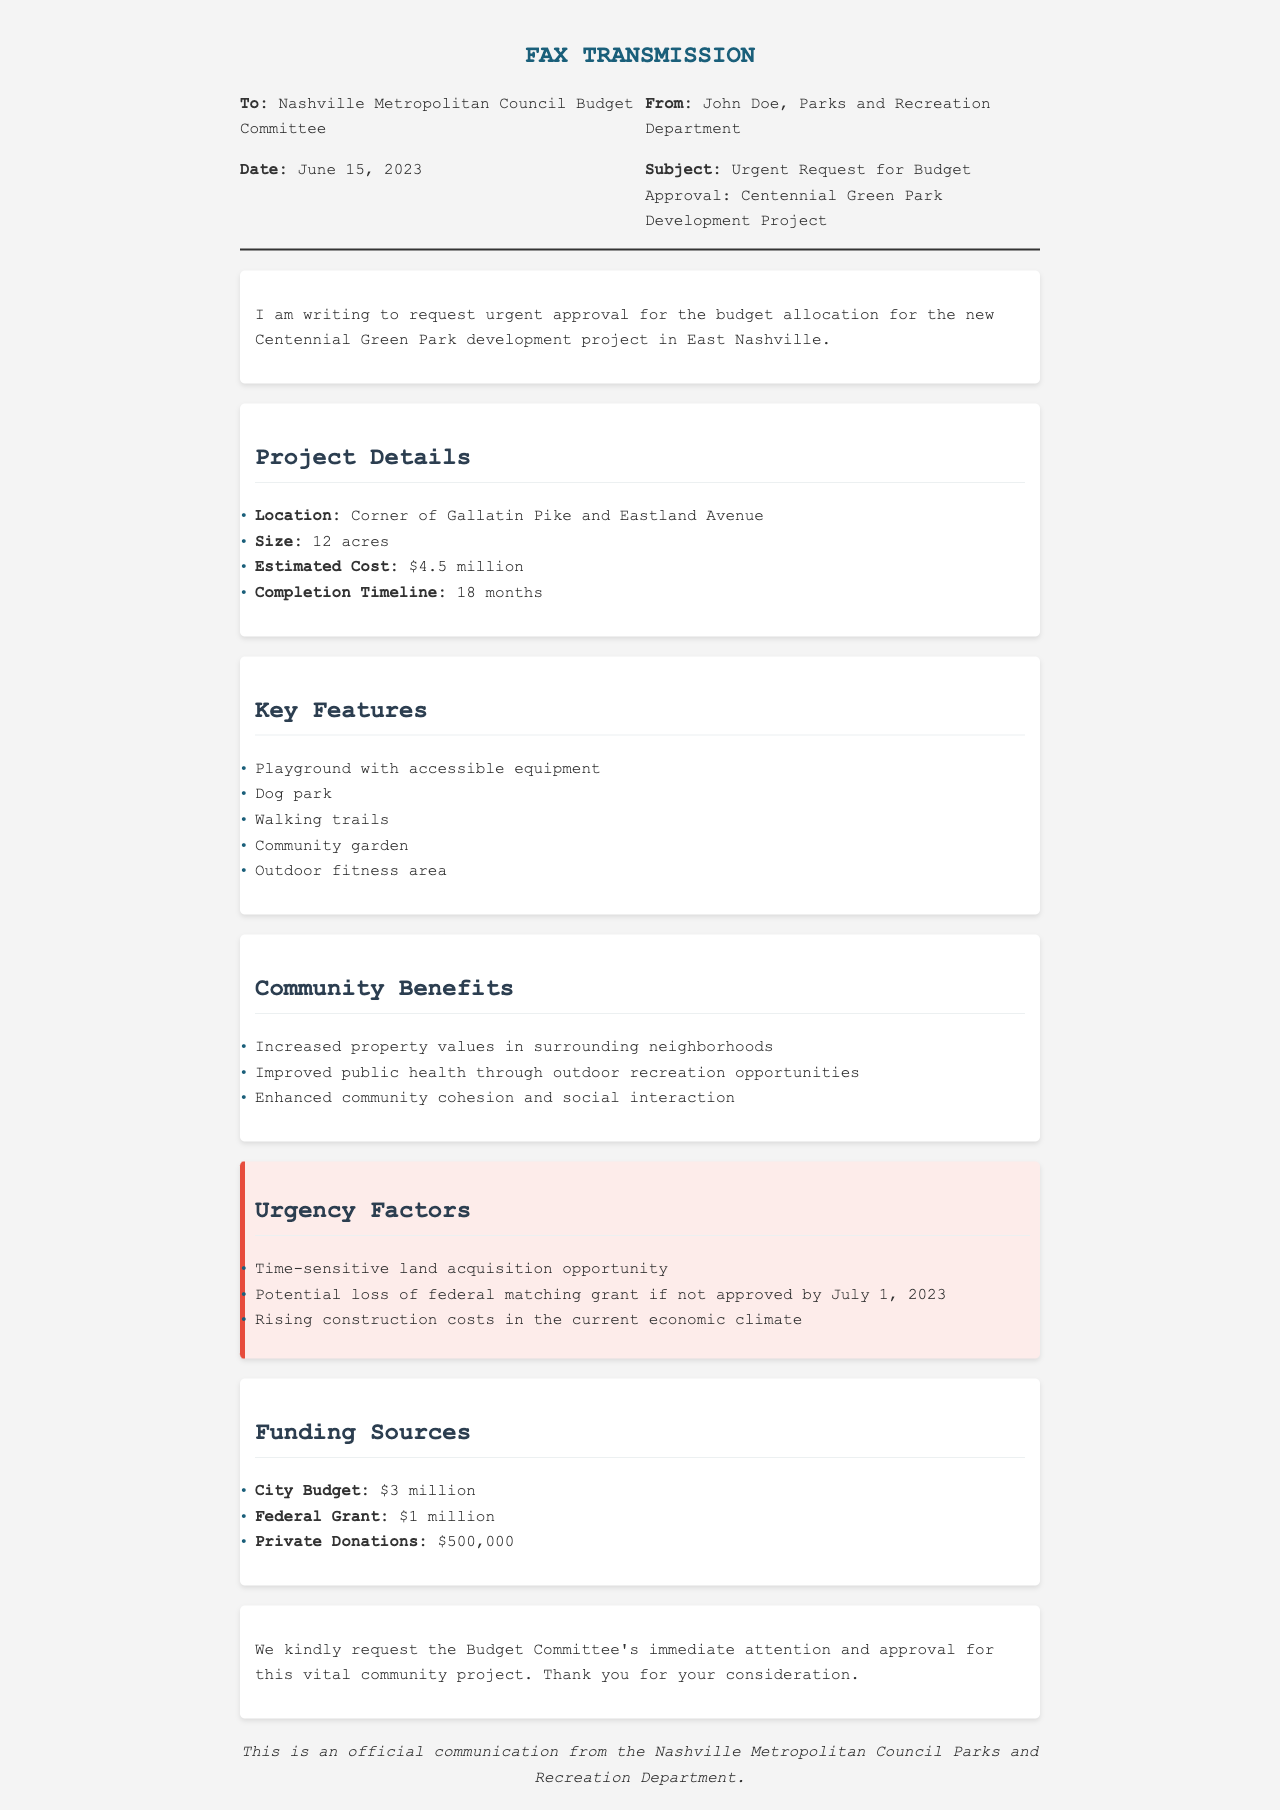What is the date of the fax? The date of the fax can be found in the header information of the document, which is June 15, 2023.
Answer: June 15, 2023 Who is the sender of the fax? The sender's name is mentioned in the header part of the fax, specifically as John Doe from the Parks and Recreation Department.
Answer: John Doe What is the estimated cost of the project? The estimated cost is specifically mentioned under the project details section as $4.5 million.
Answer: $4.5 million What is one of the key features of the park? Key features are listed in the document, one of which is the playground with accessible equipment.
Answer: Playground with accessible equipment What is the total amount of funding from the city budget? The document specifies that the city budget allocation for the project is $3 million.
Answer: $3 million What is the completion timeline for the project? The completion timeline is stated under project details in the document as 18 months.
Answer: 18 months What is a community benefit mentioned in the document? The document lists community benefits, including increased property values in surrounding neighborhoods.
Answer: Increased property values in surrounding neighborhoods What is a reason for the urgency of the request? One of the urgency factors mentioned is the potential loss of federal matching grant if not approved by July 1, 2023.
Answer: Potential loss of federal matching grant if not approved by July 1, 2023 What is the subject of the fax? The subject is clearly stated in the header of the fax as "Urgent Request for Budget Approval: Centennial Green Park Development Project."
Answer: Urgent Request for Budget Approval: Centennial Green Park Development Project 